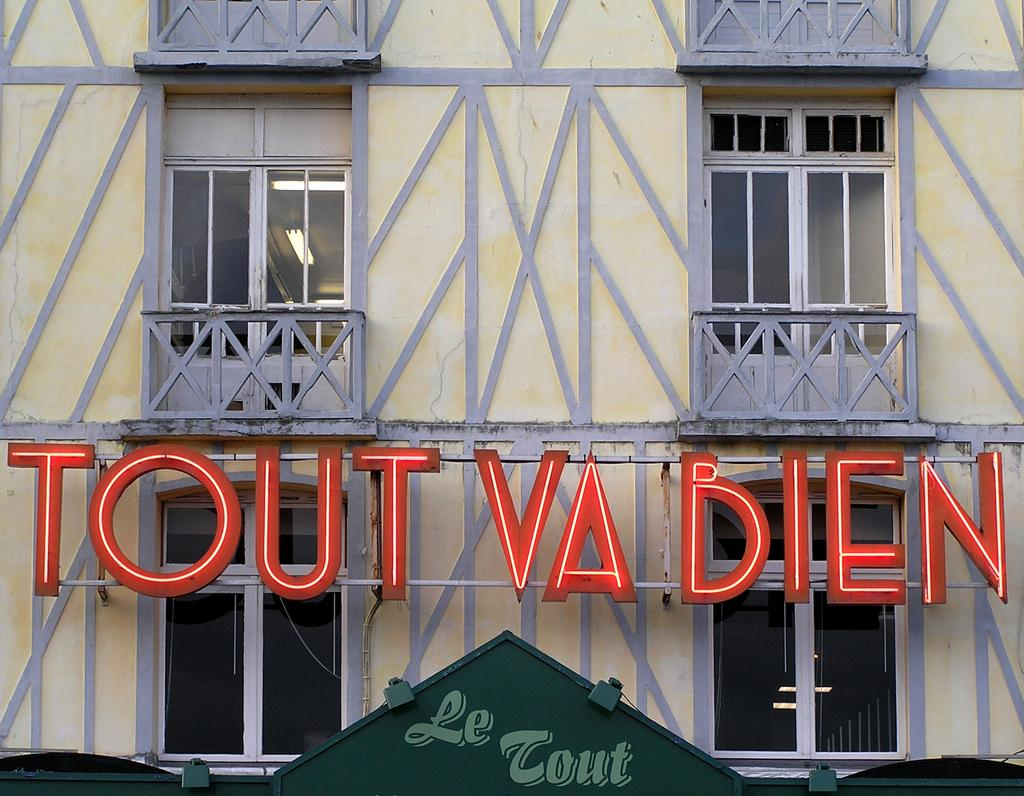What type of structure is visible in the image? There is a building in the image. What feature of the building is mentioned in the facts? The building has multiple windows and lights present on the roof. What is located in front of the building? There is a hoarding in the front of the building. What type of cast can be seen on the building's facade in the image? There is no cast visible on the building's facade in the image. 